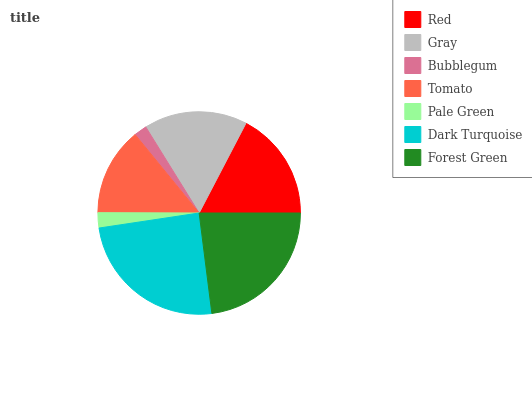Is Bubblegum the minimum?
Answer yes or no. Yes. Is Dark Turquoise the maximum?
Answer yes or no. Yes. Is Gray the minimum?
Answer yes or no. No. Is Gray the maximum?
Answer yes or no. No. Is Red greater than Gray?
Answer yes or no. Yes. Is Gray less than Red?
Answer yes or no. Yes. Is Gray greater than Red?
Answer yes or no. No. Is Red less than Gray?
Answer yes or no. No. Is Gray the high median?
Answer yes or no. Yes. Is Gray the low median?
Answer yes or no. Yes. Is Bubblegum the high median?
Answer yes or no. No. Is Tomato the low median?
Answer yes or no. No. 